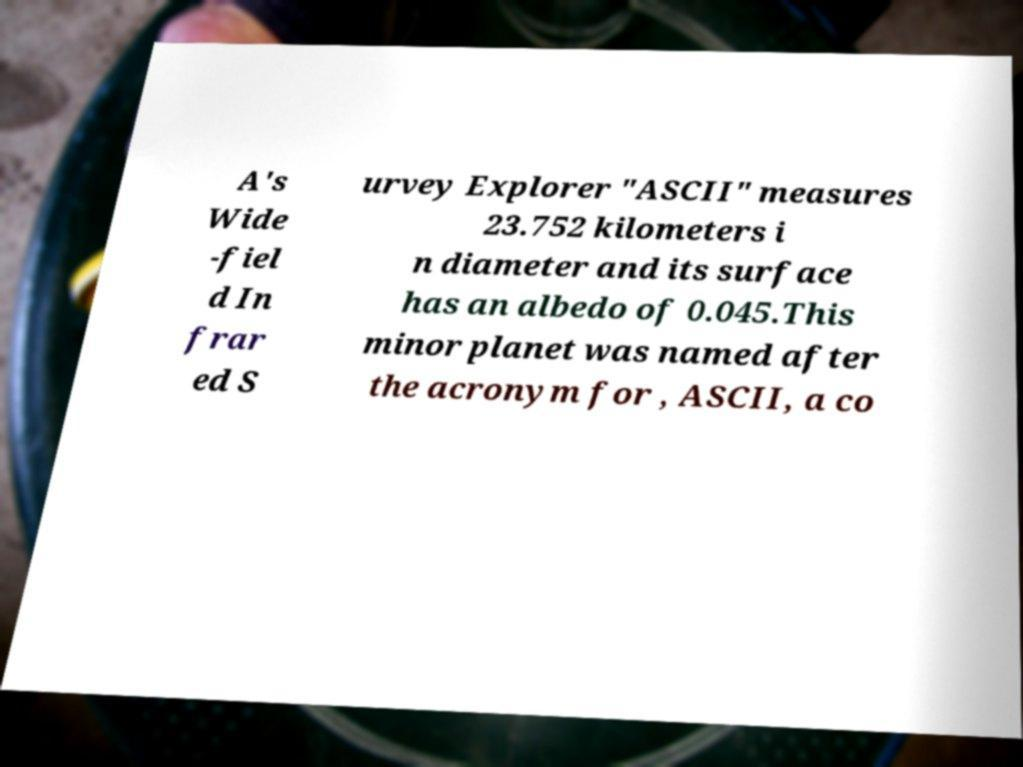Could you extract and type out the text from this image? A's Wide -fiel d In frar ed S urvey Explorer "ASCII" measures 23.752 kilometers i n diameter and its surface has an albedo of 0.045.This minor planet was named after the acronym for , ASCII, a co 